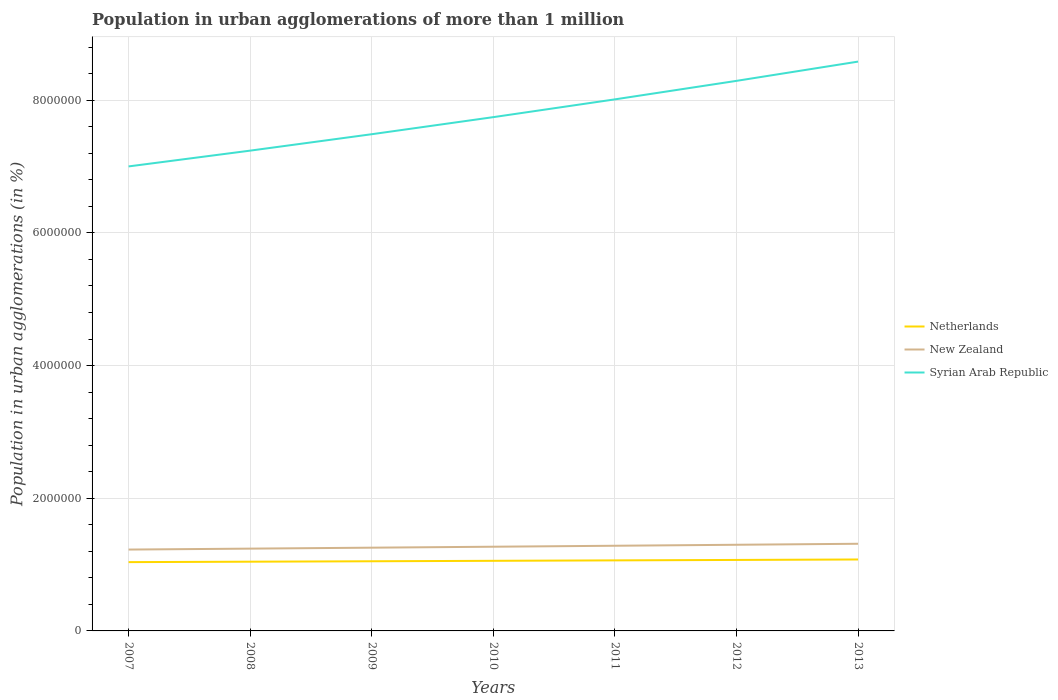How many different coloured lines are there?
Your answer should be compact. 3. Does the line corresponding to Netherlands intersect with the line corresponding to Syrian Arab Republic?
Your answer should be very brief. No. Across all years, what is the maximum population in urban agglomerations in New Zealand?
Make the answer very short. 1.23e+06. In which year was the population in urban agglomerations in Netherlands maximum?
Provide a succinct answer. 2007. What is the total population in urban agglomerations in Syrian Arab Republic in the graph?
Provide a succinct answer. -1.05e+06. What is the difference between the highest and the second highest population in urban agglomerations in Syrian Arab Republic?
Your answer should be compact. 1.58e+06. What is the difference between the highest and the lowest population in urban agglomerations in Syrian Arab Republic?
Your answer should be very brief. 3. Is the population in urban agglomerations in Netherlands strictly greater than the population in urban agglomerations in Syrian Arab Republic over the years?
Offer a terse response. Yes. How many years are there in the graph?
Your answer should be very brief. 7. What is the difference between two consecutive major ticks on the Y-axis?
Provide a succinct answer. 2.00e+06. Are the values on the major ticks of Y-axis written in scientific E-notation?
Your response must be concise. No. Does the graph contain grids?
Offer a terse response. Yes. Where does the legend appear in the graph?
Ensure brevity in your answer.  Center right. How many legend labels are there?
Your answer should be very brief. 3. What is the title of the graph?
Make the answer very short. Population in urban agglomerations of more than 1 million. Does "French Polynesia" appear as one of the legend labels in the graph?
Offer a very short reply. No. What is the label or title of the Y-axis?
Offer a terse response. Population in urban agglomerations (in %). What is the Population in urban agglomerations (in %) in Netherlands in 2007?
Make the answer very short. 1.04e+06. What is the Population in urban agglomerations (in %) of New Zealand in 2007?
Provide a succinct answer. 1.23e+06. What is the Population in urban agglomerations (in %) of Syrian Arab Republic in 2007?
Give a very brief answer. 7.00e+06. What is the Population in urban agglomerations (in %) of Netherlands in 2008?
Provide a short and direct response. 1.04e+06. What is the Population in urban agglomerations (in %) of New Zealand in 2008?
Your answer should be very brief. 1.24e+06. What is the Population in urban agglomerations (in %) of Syrian Arab Republic in 2008?
Ensure brevity in your answer.  7.24e+06. What is the Population in urban agglomerations (in %) in Netherlands in 2009?
Ensure brevity in your answer.  1.05e+06. What is the Population in urban agglomerations (in %) of New Zealand in 2009?
Keep it short and to the point. 1.25e+06. What is the Population in urban agglomerations (in %) in Syrian Arab Republic in 2009?
Provide a succinct answer. 7.49e+06. What is the Population in urban agglomerations (in %) of Netherlands in 2010?
Ensure brevity in your answer.  1.06e+06. What is the Population in urban agglomerations (in %) of New Zealand in 2010?
Offer a very short reply. 1.27e+06. What is the Population in urban agglomerations (in %) of Syrian Arab Republic in 2010?
Offer a very short reply. 7.74e+06. What is the Population in urban agglomerations (in %) in Netherlands in 2011?
Your response must be concise. 1.06e+06. What is the Population in urban agglomerations (in %) of New Zealand in 2011?
Ensure brevity in your answer.  1.28e+06. What is the Population in urban agglomerations (in %) in Syrian Arab Republic in 2011?
Your answer should be very brief. 8.01e+06. What is the Population in urban agglomerations (in %) of Netherlands in 2012?
Provide a short and direct response. 1.07e+06. What is the Population in urban agglomerations (in %) of New Zealand in 2012?
Provide a short and direct response. 1.30e+06. What is the Population in urban agglomerations (in %) in Syrian Arab Republic in 2012?
Keep it short and to the point. 8.29e+06. What is the Population in urban agglomerations (in %) of Netherlands in 2013?
Keep it short and to the point. 1.08e+06. What is the Population in urban agglomerations (in %) in New Zealand in 2013?
Your answer should be compact. 1.31e+06. What is the Population in urban agglomerations (in %) in Syrian Arab Republic in 2013?
Offer a very short reply. 8.58e+06. Across all years, what is the maximum Population in urban agglomerations (in %) in Netherlands?
Give a very brief answer. 1.08e+06. Across all years, what is the maximum Population in urban agglomerations (in %) in New Zealand?
Provide a succinct answer. 1.31e+06. Across all years, what is the maximum Population in urban agglomerations (in %) in Syrian Arab Republic?
Keep it short and to the point. 8.58e+06. Across all years, what is the minimum Population in urban agglomerations (in %) in Netherlands?
Your answer should be very brief. 1.04e+06. Across all years, what is the minimum Population in urban agglomerations (in %) in New Zealand?
Your answer should be very brief. 1.23e+06. Across all years, what is the minimum Population in urban agglomerations (in %) in Syrian Arab Republic?
Your answer should be very brief. 7.00e+06. What is the total Population in urban agglomerations (in %) in Netherlands in the graph?
Provide a short and direct response. 7.40e+06. What is the total Population in urban agglomerations (in %) in New Zealand in the graph?
Ensure brevity in your answer.  8.89e+06. What is the total Population in urban agglomerations (in %) in Syrian Arab Republic in the graph?
Your response must be concise. 5.44e+07. What is the difference between the Population in urban agglomerations (in %) of Netherlands in 2007 and that in 2008?
Give a very brief answer. -6540. What is the difference between the Population in urban agglomerations (in %) in New Zealand in 2007 and that in 2008?
Offer a very short reply. -1.41e+04. What is the difference between the Population in urban agglomerations (in %) of Syrian Arab Republic in 2007 and that in 2008?
Your answer should be compact. -2.38e+05. What is the difference between the Population in urban agglomerations (in %) in Netherlands in 2007 and that in 2009?
Make the answer very short. -1.31e+04. What is the difference between the Population in urban agglomerations (in %) of New Zealand in 2007 and that in 2009?
Offer a terse response. -2.84e+04. What is the difference between the Population in urban agglomerations (in %) in Syrian Arab Republic in 2007 and that in 2009?
Your response must be concise. -4.85e+05. What is the difference between the Population in urban agglomerations (in %) in Netherlands in 2007 and that in 2010?
Your response must be concise. -1.97e+04. What is the difference between the Population in urban agglomerations (in %) of New Zealand in 2007 and that in 2010?
Your answer should be very brief. -4.29e+04. What is the difference between the Population in urban agglomerations (in %) of Syrian Arab Republic in 2007 and that in 2010?
Make the answer very short. -7.43e+05. What is the difference between the Population in urban agglomerations (in %) of Netherlands in 2007 and that in 2011?
Ensure brevity in your answer.  -2.64e+04. What is the difference between the Population in urban agglomerations (in %) of New Zealand in 2007 and that in 2011?
Give a very brief answer. -5.75e+04. What is the difference between the Population in urban agglomerations (in %) in Syrian Arab Republic in 2007 and that in 2011?
Keep it short and to the point. -1.01e+06. What is the difference between the Population in urban agglomerations (in %) of Netherlands in 2007 and that in 2012?
Give a very brief answer. -3.31e+04. What is the difference between the Population in urban agglomerations (in %) of New Zealand in 2007 and that in 2012?
Your answer should be very brief. -7.23e+04. What is the difference between the Population in urban agglomerations (in %) of Syrian Arab Republic in 2007 and that in 2012?
Offer a very short reply. -1.29e+06. What is the difference between the Population in urban agglomerations (in %) in Netherlands in 2007 and that in 2013?
Ensure brevity in your answer.  -3.98e+04. What is the difference between the Population in urban agglomerations (in %) in New Zealand in 2007 and that in 2013?
Provide a short and direct response. -8.72e+04. What is the difference between the Population in urban agglomerations (in %) of Syrian Arab Republic in 2007 and that in 2013?
Offer a very short reply. -1.58e+06. What is the difference between the Population in urban agglomerations (in %) in Netherlands in 2008 and that in 2009?
Keep it short and to the point. -6563. What is the difference between the Population in urban agglomerations (in %) of New Zealand in 2008 and that in 2009?
Give a very brief answer. -1.43e+04. What is the difference between the Population in urban agglomerations (in %) of Syrian Arab Republic in 2008 and that in 2009?
Your response must be concise. -2.47e+05. What is the difference between the Population in urban agglomerations (in %) in Netherlands in 2008 and that in 2010?
Make the answer very short. -1.32e+04. What is the difference between the Population in urban agglomerations (in %) of New Zealand in 2008 and that in 2010?
Provide a short and direct response. -2.87e+04. What is the difference between the Population in urban agglomerations (in %) of Syrian Arab Republic in 2008 and that in 2010?
Your answer should be very brief. -5.05e+05. What is the difference between the Population in urban agglomerations (in %) of Netherlands in 2008 and that in 2011?
Make the answer very short. -1.98e+04. What is the difference between the Population in urban agglomerations (in %) in New Zealand in 2008 and that in 2011?
Offer a very short reply. -4.33e+04. What is the difference between the Population in urban agglomerations (in %) in Syrian Arab Republic in 2008 and that in 2011?
Keep it short and to the point. -7.73e+05. What is the difference between the Population in urban agglomerations (in %) of Netherlands in 2008 and that in 2012?
Offer a very short reply. -2.65e+04. What is the difference between the Population in urban agglomerations (in %) in New Zealand in 2008 and that in 2012?
Provide a succinct answer. -5.81e+04. What is the difference between the Population in urban agglomerations (in %) in Syrian Arab Republic in 2008 and that in 2012?
Your answer should be compact. -1.05e+06. What is the difference between the Population in urban agglomerations (in %) in Netherlands in 2008 and that in 2013?
Provide a short and direct response. -3.33e+04. What is the difference between the Population in urban agglomerations (in %) of New Zealand in 2008 and that in 2013?
Your answer should be compact. -7.31e+04. What is the difference between the Population in urban agglomerations (in %) of Syrian Arab Republic in 2008 and that in 2013?
Make the answer very short. -1.34e+06. What is the difference between the Population in urban agglomerations (in %) in Netherlands in 2009 and that in 2010?
Your answer should be compact. -6614. What is the difference between the Population in urban agglomerations (in %) in New Zealand in 2009 and that in 2010?
Offer a terse response. -1.45e+04. What is the difference between the Population in urban agglomerations (in %) in Syrian Arab Republic in 2009 and that in 2010?
Your answer should be very brief. -2.57e+05. What is the difference between the Population in urban agglomerations (in %) in Netherlands in 2009 and that in 2011?
Make the answer very short. -1.33e+04. What is the difference between the Population in urban agglomerations (in %) in New Zealand in 2009 and that in 2011?
Offer a very short reply. -2.91e+04. What is the difference between the Population in urban agglomerations (in %) in Syrian Arab Republic in 2009 and that in 2011?
Give a very brief answer. -5.25e+05. What is the difference between the Population in urban agglomerations (in %) of Netherlands in 2009 and that in 2012?
Offer a very short reply. -2.00e+04. What is the difference between the Population in urban agglomerations (in %) of New Zealand in 2009 and that in 2012?
Offer a very short reply. -4.39e+04. What is the difference between the Population in urban agglomerations (in %) in Syrian Arab Republic in 2009 and that in 2012?
Your answer should be very brief. -8.04e+05. What is the difference between the Population in urban agglomerations (in %) of Netherlands in 2009 and that in 2013?
Give a very brief answer. -2.67e+04. What is the difference between the Population in urban agglomerations (in %) of New Zealand in 2009 and that in 2013?
Provide a succinct answer. -5.88e+04. What is the difference between the Population in urban agglomerations (in %) of Syrian Arab Republic in 2009 and that in 2013?
Keep it short and to the point. -1.09e+06. What is the difference between the Population in urban agglomerations (in %) in Netherlands in 2010 and that in 2011?
Provide a succinct answer. -6656. What is the difference between the Population in urban agglomerations (in %) in New Zealand in 2010 and that in 2011?
Provide a succinct answer. -1.46e+04. What is the difference between the Population in urban agglomerations (in %) in Syrian Arab Republic in 2010 and that in 2011?
Your answer should be compact. -2.68e+05. What is the difference between the Population in urban agglomerations (in %) of Netherlands in 2010 and that in 2012?
Your answer should be compact. -1.34e+04. What is the difference between the Population in urban agglomerations (in %) of New Zealand in 2010 and that in 2012?
Provide a short and direct response. -2.94e+04. What is the difference between the Population in urban agglomerations (in %) of Syrian Arab Republic in 2010 and that in 2012?
Offer a very short reply. -5.47e+05. What is the difference between the Population in urban agglomerations (in %) in Netherlands in 2010 and that in 2013?
Provide a succinct answer. -2.01e+04. What is the difference between the Population in urban agglomerations (in %) in New Zealand in 2010 and that in 2013?
Give a very brief answer. -4.44e+04. What is the difference between the Population in urban agglomerations (in %) of Syrian Arab Republic in 2010 and that in 2013?
Provide a short and direct response. -8.37e+05. What is the difference between the Population in urban agglomerations (in %) in Netherlands in 2011 and that in 2012?
Ensure brevity in your answer.  -6697. What is the difference between the Population in urban agglomerations (in %) in New Zealand in 2011 and that in 2012?
Give a very brief answer. -1.48e+04. What is the difference between the Population in urban agglomerations (in %) of Syrian Arab Republic in 2011 and that in 2012?
Offer a very short reply. -2.79e+05. What is the difference between the Population in urban agglomerations (in %) in Netherlands in 2011 and that in 2013?
Ensure brevity in your answer.  -1.34e+04. What is the difference between the Population in urban agglomerations (in %) of New Zealand in 2011 and that in 2013?
Provide a succinct answer. -2.97e+04. What is the difference between the Population in urban agglomerations (in %) in Syrian Arab Republic in 2011 and that in 2013?
Ensure brevity in your answer.  -5.69e+05. What is the difference between the Population in urban agglomerations (in %) in Netherlands in 2012 and that in 2013?
Make the answer very short. -6740. What is the difference between the Population in urban agglomerations (in %) in New Zealand in 2012 and that in 2013?
Your response must be concise. -1.49e+04. What is the difference between the Population in urban agglomerations (in %) of Syrian Arab Republic in 2012 and that in 2013?
Your response must be concise. -2.90e+05. What is the difference between the Population in urban agglomerations (in %) in Netherlands in 2007 and the Population in urban agglomerations (in %) in New Zealand in 2008?
Your answer should be compact. -2.04e+05. What is the difference between the Population in urban agglomerations (in %) in Netherlands in 2007 and the Population in urban agglomerations (in %) in Syrian Arab Republic in 2008?
Offer a very short reply. -6.20e+06. What is the difference between the Population in urban agglomerations (in %) in New Zealand in 2007 and the Population in urban agglomerations (in %) in Syrian Arab Republic in 2008?
Give a very brief answer. -6.01e+06. What is the difference between the Population in urban agglomerations (in %) in Netherlands in 2007 and the Population in urban agglomerations (in %) in New Zealand in 2009?
Provide a succinct answer. -2.18e+05. What is the difference between the Population in urban agglomerations (in %) in Netherlands in 2007 and the Population in urban agglomerations (in %) in Syrian Arab Republic in 2009?
Your answer should be compact. -6.45e+06. What is the difference between the Population in urban agglomerations (in %) in New Zealand in 2007 and the Population in urban agglomerations (in %) in Syrian Arab Republic in 2009?
Ensure brevity in your answer.  -6.26e+06. What is the difference between the Population in urban agglomerations (in %) of Netherlands in 2007 and the Population in urban agglomerations (in %) of New Zealand in 2010?
Ensure brevity in your answer.  -2.32e+05. What is the difference between the Population in urban agglomerations (in %) of Netherlands in 2007 and the Population in urban agglomerations (in %) of Syrian Arab Republic in 2010?
Ensure brevity in your answer.  -6.71e+06. What is the difference between the Population in urban agglomerations (in %) in New Zealand in 2007 and the Population in urban agglomerations (in %) in Syrian Arab Republic in 2010?
Ensure brevity in your answer.  -6.52e+06. What is the difference between the Population in urban agglomerations (in %) of Netherlands in 2007 and the Population in urban agglomerations (in %) of New Zealand in 2011?
Your answer should be very brief. -2.47e+05. What is the difference between the Population in urban agglomerations (in %) of Netherlands in 2007 and the Population in urban agglomerations (in %) of Syrian Arab Republic in 2011?
Your answer should be compact. -6.98e+06. What is the difference between the Population in urban agglomerations (in %) of New Zealand in 2007 and the Population in urban agglomerations (in %) of Syrian Arab Republic in 2011?
Give a very brief answer. -6.79e+06. What is the difference between the Population in urban agglomerations (in %) in Netherlands in 2007 and the Population in urban agglomerations (in %) in New Zealand in 2012?
Give a very brief answer. -2.62e+05. What is the difference between the Population in urban agglomerations (in %) of Netherlands in 2007 and the Population in urban agglomerations (in %) of Syrian Arab Republic in 2012?
Keep it short and to the point. -7.25e+06. What is the difference between the Population in urban agglomerations (in %) in New Zealand in 2007 and the Population in urban agglomerations (in %) in Syrian Arab Republic in 2012?
Your answer should be very brief. -7.06e+06. What is the difference between the Population in urban agglomerations (in %) in Netherlands in 2007 and the Population in urban agglomerations (in %) in New Zealand in 2013?
Offer a terse response. -2.77e+05. What is the difference between the Population in urban agglomerations (in %) in Netherlands in 2007 and the Population in urban agglomerations (in %) in Syrian Arab Republic in 2013?
Give a very brief answer. -7.54e+06. What is the difference between the Population in urban agglomerations (in %) of New Zealand in 2007 and the Population in urban agglomerations (in %) of Syrian Arab Republic in 2013?
Keep it short and to the point. -7.36e+06. What is the difference between the Population in urban agglomerations (in %) in Netherlands in 2008 and the Population in urban agglomerations (in %) in New Zealand in 2009?
Provide a succinct answer. -2.11e+05. What is the difference between the Population in urban agglomerations (in %) of Netherlands in 2008 and the Population in urban agglomerations (in %) of Syrian Arab Republic in 2009?
Offer a terse response. -6.44e+06. What is the difference between the Population in urban agglomerations (in %) of New Zealand in 2008 and the Population in urban agglomerations (in %) of Syrian Arab Republic in 2009?
Offer a very short reply. -6.25e+06. What is the difference between the Population in urban agglomerations (in %) of Netherlands in 2008 and the Population in urban agglomerations (in %) of New Zealand in 2010?
Keep it short and to the point. -2.26e+05. What is the difference between the Population in urban agglomerations (in %) of Netherlands in 2008 and the Population in urban agglomerations (in %) of Syrian Arab Republic in 2010?
Your answer should be compact. -6.70e+06. What is the difference between the Population in urban agglomerations (in %) of New Zealand in 2008 and the Population in urban agglomerations (in %) of Syrian Arab Republic in 2010?
Give a very brief answer. -6.50e+06. What is the difference between the Population in urban agglomerations (in %) in Netherlands in 2008 and the Population in urban agglomerations (in %) in New Zealand in 2011?
Offer a terse response. -2.40e+05. What is the difference between the Population in urban agglomerations (in %) of Netherlands in 2008 and the Population in urban agglomerations (in %) of Syrian Arab Republic in 2011?
Your answer should be compact. -6.97e+06. What is the difference between the Population in urban agglomerations (in %) in New Zealand in 2008 and the Population in urban agglomerations (in %) in Syrian Arab Republic in 2011?
Offer a terse response. -6.77e+06. What is the difference between the Population in urban agglomerations (in %) of Netherlands in 2008 and the Population in urban agglomerations (in %) of New Zealand in 2012?
Make the answer very short. -2.55e+05. What is the difference between the Population in urban agglomerations (in %) in Netherlands in 2008 and the Population in urban agglomerations (in %) in Syrian Arab Republic in 2012?
Give a very brief answer. -7.25e+06. What is the difference between the Population in urban agglomerations (in %) of New Zealand in 2008 and the Population in urban agglomerations (in %) of Syrian Arab Republic in 2012?
Provide a succinct answer. -7.05e+06. What is the difference between the Population in urban agglomerations (in %) in Netherlands in 2008 and the Population in urban agglomerations (in %) in New Zealand in 2013?
Your answer should be compact. -2.70e+05. What is the difference between the Population in urban agglomerations (in %) in Netherlands in 2008 and the Population in urban agglomerations (in %) in Syrian Arab Republic in 2013?
Your answer should be compact. -7.54e+06. What is the difference between the Population in urban agglomerations (in %) in New Zealand in 2008 and the Population in urban agglomerations (in %) in Syrian Arab Republic in 2013?
Give a very brief answer. -7.34e+06. What is the difference between the Population in urban agglomerations (in %) in Netherlands in 2009 and the Population in urban agglomerations (in %) in New Zealand in 2010?
Your answer should be very brief. -2.19e+05. What is the difference between the Population in urban agglomerations (in %) in Netherlands in 2009 and the Population in urban agglomerations (in %) in Syrian Arab Republic in 2010?
Make the answer very short. -6.69e+06. What is the difference between the Population in urban agglomerations (in %) in New Zealand in 2009 and the Population in urban agglomerations (in %) in Syrian Arab Republic in 2010?
Your answer should be compact. -6.49e+06. What is the difference between the Population in urban agglomerations (in %) of Netherlands in 2009 and the Population in urban agglomerations (in %) of New Zealand in 2011?
Provide a short and direct response. -2.34e+05. What is the difference between the Population in urban agglomerations (in %) of Netherlands in 2009 and the Population in urban agglomerations (in %) of Syrian Arab Republic in 2011?
Offer a very short reply. -6.96e+06. What is the difference between the Population in urban agglomerations (in %) of New Zealand in 2009 and the Population in urban agglomerations (in %) of Syrian Arab Republic in 2011?
Make the answer very short. -6.76e+06. What is the difference between the Population in urban agglomerations (in %) of Netherlands in 2009 and the Population in urban agglomerations (in %) of New Zealand in 2012?
Make the answer very short. -2.49e+05. What is the difference between the Population in urban agglomerations (in %) in Netherlands in 2009 and the Population in urban agglomerations (in %) in Syrian Arab Republic in 2012?
Give a very brief answer. -7.24e+06. What is the difference between the Population in urban agglomerations (in %) in New Zealand in 2009 and the Population in urban agglomerations (in %) in Syrian Arab Republic in 2012?
Offer a terse response. -7.04e+06. What is the difference between the Population in urban agglomerations (in %) of Netherlands in 2009 and the Population in urban agglomerations (in %) of New Zealand in 2013?
Make the answer very short. -2.64e+05. What is the difference between the Population in urban agglomerations (in %) in Netherlands in 2009 and the Population in urban agglomerations (in %) in Syrian Arab Republic in 2013?
Offer a terse response. -7.53e+06. What is the difference between the Population in urban agglomerations (in %) of New Zealand in 2009 and the Population in urban agglomerations (in %) of Syrian Arab Republic in 2013?
Give a very brief answer. -7.33e+06. What is the difference between the Population in urban agglomerations (in %) of Netherlands in 2010 and the Population in urban agglomerations (in %) of New Zealand in 2011?
Keep it short and to the point. -2.27e+05. What is the difference between the Population in urban agglomerations (in %) in Netherlands in 2010 and the Population in urban agglomerations (in %) in Syrian Arab Republic in 2011?
Offer a very short reply. -6.96e+06. What is the difference between the Population in urban agglomerations (in %) of New Zealand in 2010 and the Population in urban agglomerations (in %) of Syrian Arab Republic in 2011?
Your answer should be compact. -6.74e+06. What is the difference between the Population in urban agglomerations (in %) of Netherlands in 2010 and the Population in urban agglomerations (in %) of New Zealand in 2012?
Your answer should be compact. -2.42e+05. What is the difference between the Population in urban agglomerations (in %) of Netherlands in 2010 and the Population in urban agglomerations (in %) of Syrian Arab Republic in 2012?
Make the answer very short. -7.23e+06. What is the difference between the Population in urban agglomerations (in %) of New Zealand in 2010 and the Population in urban agglomerations (in %) of Syrian Arab Republic in 2012?
Ensure brevity in your answer.  -7.02e+06. What is the difference between the Population in urban agglomerations (in %) in Netherlands in 2010 and the Population in urban agglomerations (in %) in New Zealand in 2013?
Your answer should be very brief. -2.57e+05. What is the difference between the Population in urban agglomerations (in %) of Netherlands in 2010 and the Population in urban agglomerations (in %) of Syrian Arab Republic in 2013?
Provide a succinct answer. -7.53e+06. What is the difference between the Population in urban agglomerations (in %) of New Zealand in 2010 and the Population in urban agglomerations (in %) of Syrian Arab Republic in 2013?
Offer a very short reply. -7.31e+06. What is the difference between the Population in urban agglomerations (in %) in Netherlands in 2011 and the Population in urban agglomerations (in %) in New Zealand in 2012?
Provide a succinct answer. -2.35e+05. What is the difference between the Population in urban agglomerations (in %) in Netherlands in 2011 and the Population in urban agglomerations (in %) in Syrian Arab Republic in 2012?
Offer a very short reply. -7.23e+06. What is the difference between the Population in urban agglomerations (in %) in New Zealand in 2011 and the Population in urban agglomerations (in %) in Syrian Arab Republic in 2012?
Provide a short and direct response. -7.01e+06. What is the difference between the Population in urban agglomerations (in %) in Netherlands in 2011 and the Population in urban agglomerations (in %) in New Zealand in 2013?
Offer a very short reply. -2.50e+05. What is the difference between the Population in urban agglomerations (in %) in Netherlands in 2011 and the Population in urban agglomerations (in %) in Syrian Arab Republic in 2013?
Your answer should be very brief. -7.52e+06. What is the difference between the Population in urban agglomerations (in %) in New Zealand in 2011 and the Population in urban agglomerations (in %) in Syrian Arab Republic in 2013?
Provide a short and direct response. -7.30e+06. What is the difference between the Population in urban agglomerations (in %) in Netherlands in 2012 and the Population in urban agglomerations (in %) in New Zealand in 2013?
Your answer should be compact. -2.44e+05. What is the difference between the Population in urban agglomerations (in %) in Netherlands in 2012 and the Population in urban agglomerations (in %) in Syrian Arab Republic in 2013?
Provide a short and direct response. -7.51e+06. What is the difference between the Population in urban agglomerations (in %) of New Zealand in 2012 and the Population in urban agglomerations (in %) of Syrian Arab Republic in 2013?
Your response must be concise. -7.28e+06. What is the average Population in urban agglomerations (in %) in Netherlands per year?
Ensure brevity in your answer.  1.06e+06. What is the average Population in urban agglomerations (in %) in New Zealand per year?
Your response must be concise. 1.27e+06. What is the average Population in urban agglomerations (in %) in Syrian Arab Republic per year?
Make the answer very short. 7.77e+06. In the year 2007, what is the difference between the Population in urban agglomerations (in %) of Netherlands and Population in urban agglomerations (in %) of New Zealand?
Offer a terse response. -1.89e+05. In the year 2007, what is the difference between the Population in urban agglomerations (in %) of Netherlands and Population in urban agglomerations (in %) of Syrian Arab Republic?
Keep it short and to the point. -5.96e+06. In the year 2007, what is the difference between the Population in urban agglomerations (in %) in New Zealand and Population in urban agglomerations (in %) in Syrian Arab Republic?
Keep it short and to the point. -5.78e+06. In the year 2008, what is the difference between the Population in urban agglomerations (in %) in Netherlands and Population in urban agglomerations (in %) in New Zealand?
Offer a terse response. -1.97e+05. In the year 2008, what is the difference between the Population in urban agglomerations (in %) of Netherlands and Population in urban agglomerations (in %) of Syrian Arab Republic?
Your answer should be compact. -6.20e+06. In the year 2008, what is the difference between the Population in urban agglomerations (in %) of New Zealand and Population in urban agglomerations (in %) of Syrian Arab Republic?
Provide a succinct answer. -6.00e+06. In the year 2009, what is the difference between the Population in urban agglomerations (in %) of Netherlands and Population in urban agglomerations (in %) of New Zealand?
Your answer should be compact. -2.05e+05. In the year 2009, what is the difference between the Population in urban agglomerations (in %) in Netherlands and Population in urban agglomerations (in %) in Syrian Arab Republic?
Provide a short and direct response. -6.44e+06. In the year 2009, what is the difference between the Population in urban agglomerations (in %) in New Zealand and Population in urban agglomerations (in %) in Syrian Arab Republic?
Your answer should be compact. -6.23e+06. In the year 2010, what is the difference between the Population in urban agglomerations (in %) in Netherlands and Population in urban agglomerations (in %) in New Zealand?
Your answer should be compact. -2.13e+05. In the year 2010, what is the difference between the Population in urban agglomerations (in %) in Netherlands and Population in urban agglomerations (in %) in Syrian Arab Republic?
Provide a succinct answer. -6.69e+06. In the year 2010, what is the difference between the Population in urban agglomerations (in %) in New Zealand and Population in urban agglomerations (in %) in Syrian Arab Republic?
Offer a very short reply. -6.48e+06. In the year 2011, what is the difference between the Population in urban agglomerations (in %) of Netherlands and Population in urban agglomerations (in %) of New Zealand?
Make the answer very short. -2.21e+05. In the year 2011, what is the difference between the Population in urban agglomerations (in %) in Netherlands and Population in urban agglomerations (in %) in Syrian Arab Republic?
Offer a terse response. -6.95e+06. In the year 2011, what is the difference between the Population in urban agglomerations (in %) in New Zealand and Population in urban agglomerations (in %) in Syrian Arab Republic?
Offer a very short reply. -6.73e+06. In the year 2012, what is the difference between the Population in urban agglomerations (in %) in Netherlands and Population in urban agglomerations (in %) in New Zealand?
Provide a succinct answer. -2.29e+05. In the year 2012, what is the difference between the Population in urban agglomerations (in %) in Netherlands and Population in urban agglomerations (in %) in Syrian Arab Republic?
Provide a succinct answer. -7.22e+06. In the year 2012, what is the difference between the Population in urban agglomerations (in %) of New Zealand and Population in urban agglomerations (in %) of Syrian Arab Republic?
Provide a succinct answer. -6.99e+06. In the year 2013, what is the difference between the Population in urban agglomerations (in %) of Netherlands and Population in urban agglomerations (in %) of New Zealand?
Offer a very short reply. -2.37e+05. In the year 2013, what is the difference between the Population in urban agglomerations (in %) of Netherlands and Population in urban agglomerations (in %) of Syrian Arab Republic?
Provide a succinct answer. -7.50e+06. In the year 2013, what is the difference between the Population in urban agglomerations (in %) in New Zealand and Population in urban agglomerations (in %) in Syrian Arab Republic?
Your response must be concise. -7.27e+06. What is the ratio of the Population in urban agglomerations (in %) in Syrian Arab Republic in 2007 to that in 2008?
Provide a short and direct response. 0.97. What is the ratio of the Population in urban agglomerations (in %) in Netherlands in 2007 to that in 2009?
Provide a short and direct response. 0.99. What is the ratio of the Population in urban agglomerations (in %) in New Zealand in 2007 to that in 2009?
Provide a short and direct response. 0.98. What is the ratio of the Population in urban agglomerations (in %) of Syrian Arab Republic in 2007 to that in 2009?
Your answer should be very brief. 0.94. What is the ratio of the Population in urban agglomerations (in %) in Netherlands in 2007 to that in 2010?
Offer a very short reply. 0.98. What is the ratio of the Population in urban agglomerations (in %) of New Zealand in 2007 to that in 2010?
Offer a very short reply. 0.97. What is the ratio of the Population in urban agglomerations (in %) in Syrian Arab Republic in 2007 to that in 2010?
Your answer should be very brief. 0.9. What is the ratio of the Population in urban agglomerations (in %) of Netherlands in 2007 to that in 2011?
Offer a terse response. 0.98. What is the ratio of the Population in urban agglomerations (in %) in New Zealand in 2007 to that in 2011?
Provide a succinct answer. 0.96. What is the ratio of the Population in urban agglomerations (in %) in Syrian Arab Republic in 2007 to that in 2011?
Make the answer very short. 0.87. What is the ratio of the Population in urban agglomerations (in %) of Netherlands in 2007 to that in 2012?
Keep it short and to the point. 0.97. What is the ratio of the Population in urban agglomerations (in %) in New Zealand in 2007 to that in 2012?
Offer a terse response. 0.94. What is the ratio of the Population in urban agglomerations (in %) in Syrian Arab Republic in 2007 to that in 2012?
Offer a terse response. 0.84. What is the ratio of the Population in urban agglomerations (in %) in New Zealand in 2007 to that in 2013?
Ensure brevity in your answer.  0.93. What is the ratio of the Population in urban agglomerations (in %) of Syrian Arab Republic in 2007 to that in 2013?
Your response must be concise. 0.82. What is the ratio of the Population in urban agglomerations (in %) of New Zealand in 2008 to that in 2009?
Offer a very short reply. 0.99. What is the ratio of the Population in urban agglomerations (in %) in Netherlands in 2008 to that in 2010?
Provide a succinct answer. 0.99. What is the ratio of the Population in urban agglomerations (in %) of New Zealand in 2008 to that in 2010?
Keep it short and to the point. 0.98. What is the ratio of the Population in urban agglomerations (in %) in Syrian Arab Republic in 2008 to that in 2010?
Your answer should be very brief. 0.93. What is the ratio of the Population in urban agglomerations (in %) of Netherlands in 2008 to that in 2011?
Provide a succinct answer. 0.98. What is the ratio of the Population in urban agglomerations (in %) of New Zealand in 2008 to that in 2011?
Provide a short and direct response. 0.97. What is the ratio of the Population in urban agglomerations (in %) in Syrian Arab Republic in 2008 to that in 2011?
Keep it short and to the point. 0.9. What is the ratio of the Population in urban agglomerations (in %) of Netherlands in 2008 to that in 2012?
Your answer should be very brief. 0.98. What is the ratio of the Population in urban agglomerations (in %) of New Zealand in 2008 to that in 2012?
Offer a very short reply. 0.96. What is the ratio of the Population in urban agglomerations (in %) in Syrian Arab Republic in 2008 to that in 2012?
Make the answer very short. 0.87. What is the ratio of the Population in urban agglomerations (in %) of Netherlands in 2008 to that in 2013?
Provide a short and direct response. 0.97. What is the ratio of the Population in urban agglomerations (in %) of New Zealand in 2008 to that in 2013?
Offer a very short reply. 0.94. What is the ratio of the Population in urban agglomerations (in %) of Syrian Arab Republic in 2008 to that in 2013?
Give a very brief answer. 0.84. What is the ratio of the Population in urban agglomerations (in %) of Netherlands in 2009 to that in 2010?
Offer a very short reply. 0.99. What is the ratio of the Population in urban agglomerations (in %) in Syrian Arab Republic in 2009 to that in 2010?
Keep it short and to the point. 0.97. What is the ratio of the Population in urban agglomerations (in %) of Netherlands in 2009 to that in 2011?
Make the answer very short. 0.99. What is the ratio of the Population in urban agglomerations (in %) in New Zealand in 2009 to that in 2011?
Your answer should be very brief. 0.98. What is the ratio of the Population in urban agglomerations (in %) in Syrian Arab Republic in 2009 to that in 2011?
Make the answer very short. 0.93. What is the ratio of the Population in urban agglomerations (in %) in Netherlands in 2009 to that in 2012?
Ensure brevity in your answer.  0.98. What is the ratio of the Population in urban agglomerations (in %) in New Zealand in 2009 to that in 2012?
Provide a succinct answer. 0.97. What is the ratio of the Population in urban agglomerations (in %) of Syrian Arab Republic in 2009 to that in 2012?
Your answer should be very brief. 0.9. What is the ratio of the Population in urban agglomerations (in %) in Netherlands in 2009 to that in 2013?
Offer a terse response. 0.98. What is the ratio of the Population in urban agglomerations (in %) of New Zealand in 2009 to that in 2013?
Offer a very short reply. 0.96. What is the ratio of the Population in urban agglomerations (in %) of Syrian Arab Republic in 2009 to that in 2013?
Give a very brief answer. 0.87. What is the ratio of the Population in urban agglomerations (in %) in Syrian Arab Republic in 2010 to that in 2011?
Your answer should be compact. 0.97. What is the ratio of the Population in urban agglomerations (in %) in Netherlands in 2010 to that in 2012?
Provide a short and direct response. 0.99. What is the ratio of the Population in urban agglomerations (in %) in New Zealand in 2010 to that in 2012?
Your response must be concise. 0.98. What is the ratio of the Population in urban agglomerations (in %) in Syrian Arab Republic in 2010 to that in 2012?
Offer a terse response. 0.93. What is the ratio of the Population in urban agglomerations (in %) in Netherlands in 2010 to that in 2013?
Provide a succinct answer. 0.98. What is the ratio of the Population in urban agglomerations (in %) of New Zealand in 2010 to that in 2013?
Your answer should be very brief. 0.97. What is the ratio of the Population in urban agglomerations (in %) of Syrian Arab Republic in 2010 to that in 2013?
Make the answer very short. 0.9. What is the ratio of the Population in urban agglomerations (in %) in Netherlands in 2011 to that in 2012?
Make the answer very short. 0.99. What is the ratio of the Population in urban agglomerations (in %) in Syrian Arab Republic in 2011 to that in 2012?
Make the answer very short. 0.97. What is the ratio of the Population in urban agglomerations (in %) in Netherlands in 2011 to that in 2013?
Make the answer very short. 0.99. What is the ratio of the Population in urban agglomerations (in %) in New Zealand in 2011 to that in 2013?
Your answer should be compact. 0.98. What is the ratio of the Population in urban agglomerations (in %) in Syrian Arab Republic in 2011 to that in 2013?
Offer a terse response. 0.93. What is the ratio of the Population in urban agglomerations (in %) in Syrian Arab Republic in 2012 to that in 2013?
Your answer should be very brief. 0.97. What is the difference between the highest and the second highest Population in urban agglomerations (in %) in Netherlands?
Offer a very short reply. 6740. What is the difference between the highest and the second highest Population in urban agglomerations (in %) of New Zealand?
Your answer should be compact. 1.49e+04. What is the difference between the highest and the second highest Population in urban agglomerations (in %) of Syrian Arab Republic?
Provide a succinct answer. 2.90e+05. What is the difference between the highest and the lowest Population in urban agglomerations (in %) of Netherlands?
Provide a succinct answer. 3.98e+04. What is the difference between the highest and the lowest Population in urban agglomerations (in %) of New Zealand?
Offer a terse response. 8.72e+04. What is the difference between the highest and the lowest Population in urban agglomerations (in %) of Syrian Arab Republic?
Your answer should be compact. 1.58e+06. 